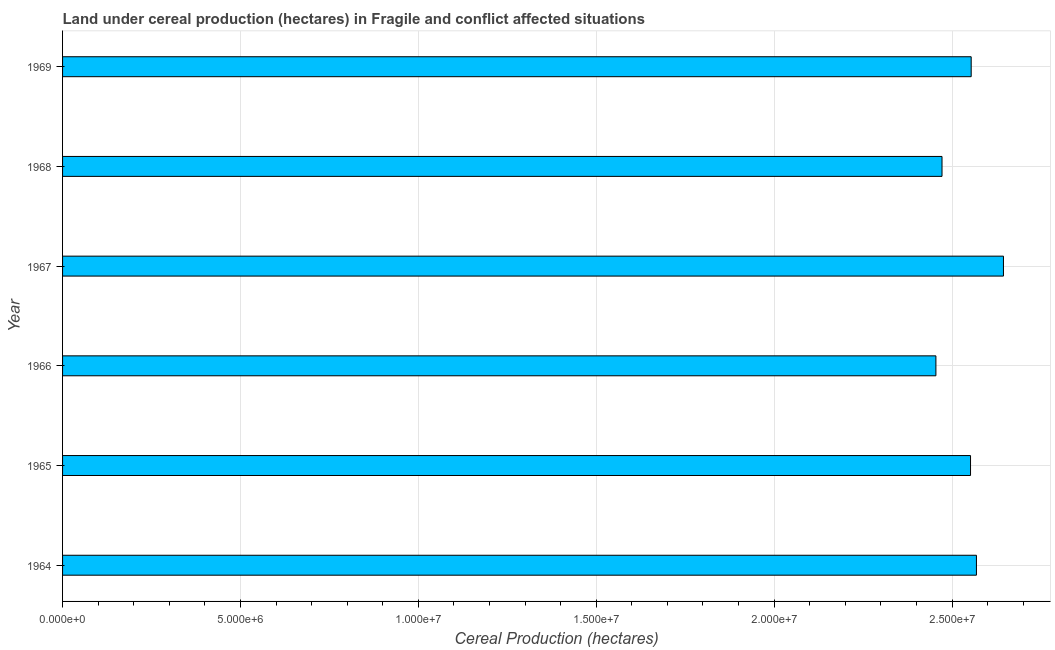Does the graph contain grids?
Your answer should be very brief. Yes. What is the title of the graph?
Keep it short and to the point. Land under cereal production (hectares) in Fragile and conflict affected situations. What is the label or title of the X-axis?
Give a very brief answer. Cereal Production (hectares). What is the land under cereal production in 1968?
Ensure brevity in your answer.  2.47e+07. Across all years, what is the maximum land under cereal production?
Provide a short and direct response. 2.64e+07. Across all years, what is the minimum land under cereal production?
Offer a very short reply. 2.45e+07. In which year was the land under cereal production maximum?
Your answer should be very brief. 1967. In which year was the land under cereal production minimum?
Provide a succinct answer. 1966. What is the sum of the land under cereal production?
Your answer should be very brief. 1.52e+08. What is the difference between the land under cereal production in 1966 and 1968?
Keep it short and to the point. -1.71e+05. What is the average land under cereal production per year?
Your response must be concise. 2.54e+07. What is the median land under cereal production?
Provide a succinct answer. 2.55e+07. In how many years, is the land under cereal production greater than 9000000 hectares?
Your answer should be very brief. 6. Do a majority of the years between 1965 and 1966 (inclusive) have land under cereal production greater than 4000000 hectares?
Your response must be concise. Yes. What is the ratio of the land under cereal production in 1964 to that in 1966?
Offer a very short reply. 1.05. Is the land under cereal production in 1964 less than that in 1968?
Make the answer very short. No. What is the difference between the highest and the second highest land under cereal production?
Keep it short and to the point. 7.59e+05. Is the sum of the land under cereal production in 1965 and 1966 greater than the maximum land under cereal production across all years?
Ensure brevity in your answer.  Yes. What is the difference between the highest and the lowest land under cereal production?
Your answer should be very brief. 1.90e+06. How many bars are there?
Offer a very short reply. 6. Are all the bars in the graph horizontal?
Your answer should be very brief. Yes. What is the difference between two consecutive major ticks on the X-axis?
Ensure brevity in your answer.  5.00e+06. Are the values on the major ticks of X-axis written in scientific E-notation?
Your answer should be very brief. Yes. What is the Cereal Production (hectares) in 1964?
Your answer should be compact. 2.57e+07. What is the Cereal Production (hectares) of 1965?
Offer a very short reply. 2.55e+07. What is the Cereal Production (hectares) in 1966?
Make the answer very short. 2.45e+07. What is the Cereal Production (hectares) in 1967?
Your answer should be compact. 2.64e+07. What is the Cereal Production (hectares) in 1968?
Your answer should be very brief. 2.47e+07. What is the Cereal Production (hectares) in 1969?
Your answer should be compact. 2.55e+07. What is the difference between the Cereal Production (hectares) in 1964 and 1965?
Make the answer very short. 1.66e+05. What is the difference between the Cereal Production (hectares) in 1964 and 1966?
Offer a terse response. 1.14e+06. What is the difference between the Cereal Production (hectares) in 1964 and 1967?
Your response must be concise. -7.59e+05. What is the difference between the Cereal Production (hectares) in 1964 and 1968?
Offer a very short reply. 9.68e+05. What is the difference between the Cereal Production (hectares) in 1964 and 1969?
Ensure brevity in your answer.  1.48e+05. What is the difference between the Cereal Production (hectares) in 1965 and 1966?
Offer a very short reply. 9.73e+05. What is the difference between the Cereal Production (hectares) in 1965 and 1967?
Provide a short and direct response. -9.25e+05. What is the difference between the Cereal Production (hectares) in 1965 and 1968?
Provide a succinct answer. 8.02e+05. What is the difference between the Cereal Production (hectares) in 1965 and 1969?
Provide a short and direct response. -1.84e+04. What is the difference between the Cereal Production (hectares) in 1966 and 1967?
Your response must be concise. -1.90e+06. What is the difference between the Cereal Production (hectares) in 1966 and 1968?
Your answer should be very brief. -1.71e+05. What is the difference between the Cereal Production (hectares) in 1966 and 1969?
Keep it short and to the point. -9.91e+05. What is the difference between the Cereal Production (hectares) in 1967 and 1968?
Your answer should be very brief. 1.73e+06. What is the difference between the Cereal Production (hectares) in 1967 and 1969?
Keep it short and to the point. 9.07e+05. What is the difference between the Cereal Production (hectares) in 1968 and 1969?
Your answer should be compact. -8.20e+05. What is the ratio of the Cereal Production (hectares) in 1964 to that in 1965?
Keep it short and to the point. 1.01. What is the ratio of the Cereal Production (hectares) in 1964 to that in 1966?
Ensure brevity in your answer.  1.05. What is the ratio of the Cereal Production (hectares) in 1964 to that in 1967?
Give a very brief answer. 0.97. What is the ratio of the Cereal Production (hectares) in 1964 to that in 1968?
Offer a terse response. 1.04. What is the ratio of the Cereal Production (hectares) in 1964 to that in 1969?
Make the answer very short. 1.01. What is the ratio of the Cereal Production (hectares) in 1965 to that in 1966?
Provide a succinct answer. 1.04. What is the ratio of the Cereal Production (hectares) in 1965 to that in 1968?
Offer a terse response. 1.03. What is the ratio of the Cereal Production (hectares) in 1965 to that in 1969?
Offer a terse response. 1. What is the ratio of the Cereal Production (hectares) in 1966 to that in 1967?
Your response must be concise. 0.93. What is the ratio of the Cereal Production (hectares) in 1966 to that in 1968?
Give a very brief answer. 0.99. What is the ratio of the Cereal Production (hectares) in 1967 to that in 1968?
Your response must be concise. 1.07. What is the ratio of the Cereal Production (hectares) in 1967 to that in 1969?
Offer a terse response. 1.04. 